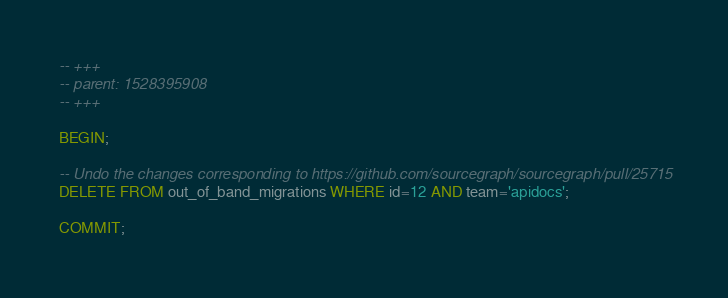Convert code to text. <code><loc_0><loc_0><loc_500><loc_500><_SQL_>-- +++
-- parent: 1528395908
-- +++

BEGIN;

-- Undo the changes corresponding to https://github.com/sourcegraph/sourcegraph/pull/25715
DELETE FROM out_of_band_migrations WHERE id=12 AND team='apidocs';

COMMIT;
</code> 